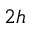Convert formula to latex. <formula><loc_0><loc_0><loc_500><loc_500>_ { 2 h }</formula> 